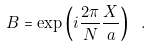Convert formula to latex. <formula><loc_0><loc_0><loc_500><loc_500>B = \exp \left ( i \frac { 2 \pi } { N } \frac { X } { a } \right ) \ .</formula> 